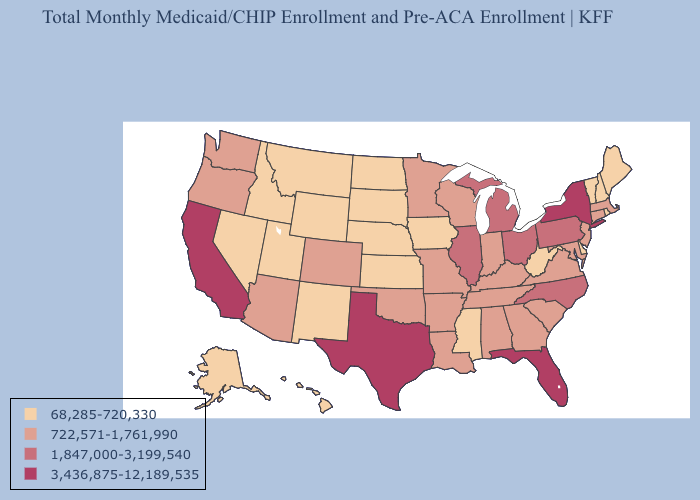Does the first symbol in the legend represent the smallest category?
Keep it brief. Yes. Among the states that border Tennessee , does Kentucky have the highest value?
Give a very brief answer. No. Name the states that have a value in the range 68,285-720,330?
Concise answer only. Alaska, Delaware, Hawaii, Idaho, Iowa, Kansas, Maine, Mississippi, Montana, Nebraska, Nevada, New Hampshire, New Mexico, North Dakota, Rhode Island, South Dakota, Utah, Vermont, West Virginia, Wyoming. Does Kansas have the lowest value in the USA?
Quick response, please. Yes. What is the highest value in the USA?
Keep it brief. 3,436,875-12,189,535. Among the states that border Kentucky , does West Virginia have the lowest value?
Concise answer only. Yes. Which states have the lowest value in the USA?
Keep it brief. Alaska, Delaware, Hawaii, Idaho, Iowa, Kansas, Maine, Mississippi, Montana, Nebraska, Nevada, New Hampshire, New Mexico, North Dakota, Rhode Island, South Dakota, Utah, Vermont, West Virginia, Wyoming. What is the value of New Jersey?
Answer briefly. 722,571-1,761,990. Among the states that border Alabama , which have the highest value?
Quick response, please. Florida. What is the lowest value in states that border New Mexico?
Short answer required. 68,285-720,330. Does New Mexico have the same value as Delaware?
Be succinct. Yes. Name the states that have a value in the range 3,436,875-12,189,535?
Keep it brief. California, Florida, New York, Texas. Among the states that border North Dakota , which have the lowest value?
Concise answer only. Montana, South Dakota. Does the map have missing data?
Concise answer only. No. What is the value of New Mexico?
Give a very brief answer. 68,285-720,330. 